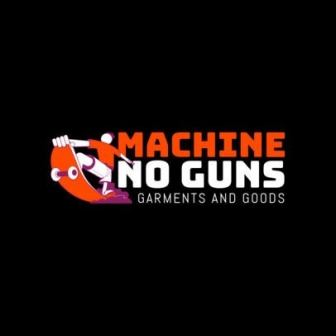Imagine the logo came to life, what would happen next? If the logo came to life, the cartoon character would likely find alternative, peaceful ways to express itself, perhaps swapping the machine gun for a musical instrument or a book. The background might transform into a lively, interactive scene reflecting a community engaged in creative and harmonious activities, fully embodying the company's values. What might you find in a store owned by this company? In a store owned by 'Machine No Guns', you would likely find a range of clothing and lifestyle goods, all designed with a focus on promoting peace and non-violence. The products could include T-shirts with positive messages, eco-friendly bags, and accessories that support a harmonious lifestyle. The store layout and decor might also reflect the sharegpt4v/same vibrant and welcoming atmosphere suggested by their logo. 